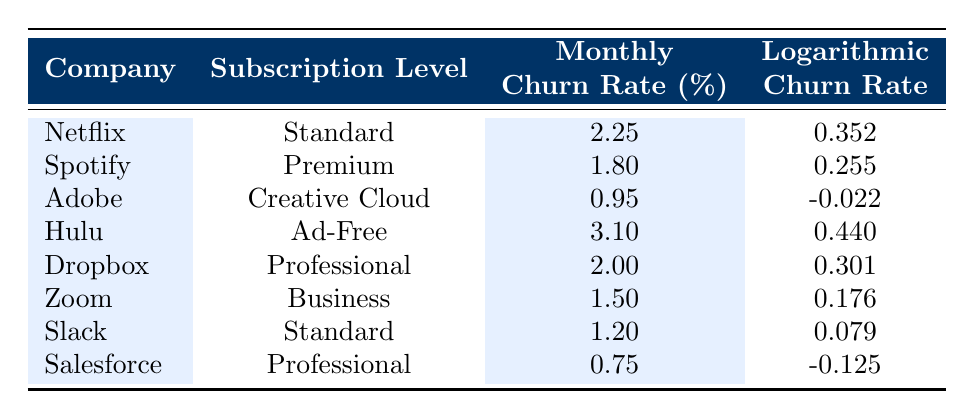What is the monthly churn rate for Hulu? The table shows the monthly churn rates for various companies. Looking at the row for Hulu, we see that the monthly churn rate is 3.10 percent.
Answer: 3.10 Which company has the lowest monthly churn rate? By scanning through the monthly churn rates of all companies listed, Salesforce has the lowest churn rate at 0.75 percent.
Answer: Salesforce What is the average monthly churn rate across all companies? To find the average, we sum the monthly churn rates: (2.25 + 1.80 + 0.95 + 3.10 + 2.00 + 1.50 + 1.20 + 0.75) = 13.55. There are 8 companies, so the average is 13.55 / 8 = 1.694375, which we can round to 1.69 percent.
Answer: 1.69 Is the logarithmic churn rate for Dropbox higher than that of Adobe? Looking at the logarithmic churn rates, Dropbox has a value of 0.301 while Adobe has -0.022. Since 0.301 is greater than -0.022, the statement is true.
Answer: Yes Which company has a monthly churn rate greater than 2 percent and what is its logarithmic churn rate? Scanning the table for companies with a monthly churn rate greater than 2 percent, we find Netflix (2.25 with a logarithmic value of 0.352) and Hulu (3.10 with a logarithmic value of 0.440). Therefore, there are two companies that meet the criteria: Netflix has a logarithmic churn rate of 0.352, and Hulu has a logarithmic churn rate of 0.440.
Answer: Netflix: 0.352, Hulu: 0.440 How many companies have a logarithmic churn rate that is negative? Examining the logarithmic churn rates, we find two companies: Adobe (-0.022) and Salesforce (-0.125), which have negative values. Therefore, there are 2 companies with negative logarithmic churn rates.
Answer: 2 What is the difference between the highest and lowest monthly churn rate? The highest monthly churn rate is 3.10 (Hulu) and the lowest is 0.75 (Salesforce). The difference is calculated as 3.10 - 0.75 = 2.35 percent.
Answer: 2.35 Is Spotify's monthly churn rate less than 2 percent? Upon checking the table, Spotify's monthly churn rate is 1.80, which is less than 2 percent, making the statement true.
Answer: Yes 